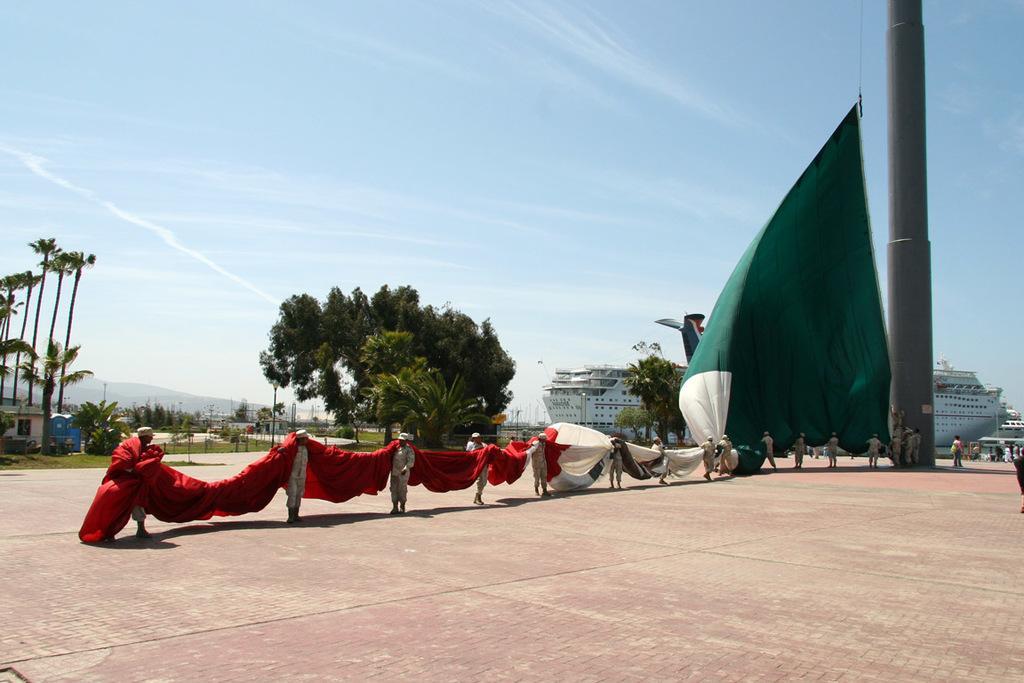Can you describe this image briefly? In this picture we can see a group of people standing on the ground and holding a cloth with their hands, trees, house, ships, poles and in the background we can see the sky with clouds. 